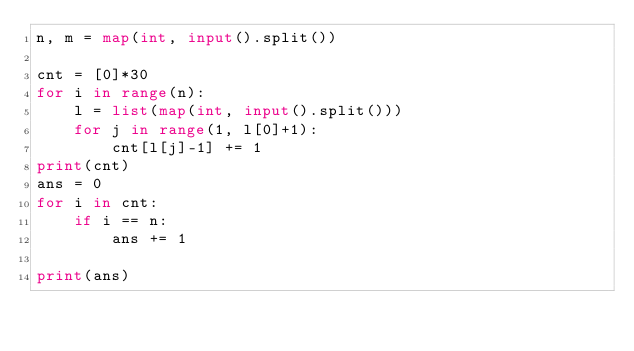Convert code to text. <code><loc_0><loc_0><loc_500><loc_500><_Python_>n, m = map(int, input().split())

cnt = [0]*30
for i in range(n):
    l = list(map(int, input().split()))
    for j in range(1, l[0]+1):
        cnt[l[j]-1] += 1
print(cnt)
ans = 0
for i in cnt:
    if i == n:
        ans += 1

print(ans)</code> 